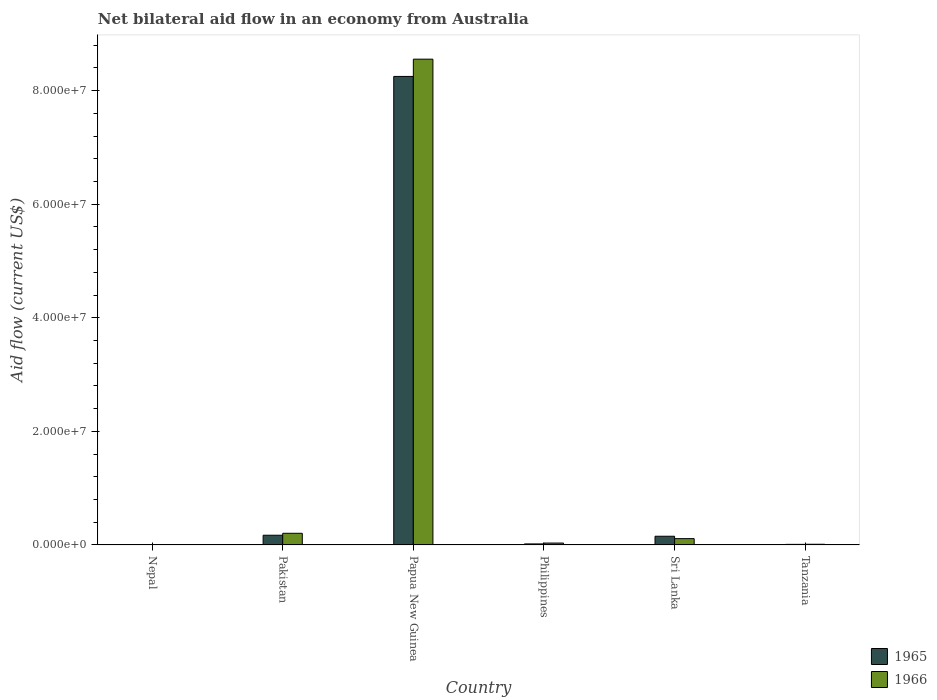How many different coloured bars are there?
Your answer should be very brief. 2. How many groups of bars are there?
Give a very brief answer. 6. Are the number of bars on each tick of the X-axis equal?
Your answer should be very brief. Yes. What is the label of the 3rd group of bars from the left?
Give a very brief answer. Papua New Guinea. What is the net bilateral aid flow in 1966 in Papua New Guinea?
Give a very brief answer. 8.56e+07. Across all countries, what is the maximum net bilateral aid flow in 1965?
Offer a very short reply. 8.25e+07. In which country was the net bilateral aid flow in 1965 maximum?
Provide a short and direct response. Papua New Guinea. In which country was the net bilateral aid flow in 1965 minimum?
Your answer should be compact. Nepal. What is the total net bilateral aid flow in 1965 in the graph?
Provide a short and direct response. 8.61e+07. What is the difference between the net bilateral aid flow in 1966 in Nepal and that in Philippines?
Your answer should be compact. -2.70e+05. What is the difference between the net bilateral aid flow in 1966 in Papua New Guinea and the net bilateral aid flow in 1965 in Philippines?
Make the answer very short. 8.54e+07. What is the average net bilateral aid flow in 1966 per country?
Offer a terse response. 1.49e+07. What is the ratio of the net bilateral aid flow in 1966 in Philippines to that in Tanzania?
Give a very brief answer. 2.75. Is the net bilateral aid flow in 1965 in Philippines less than that in Sri Lanka?
Your answer should be very brief. Yes. What is the difference between the highest and the second highest net bilateral aid flow in 1966?
Offer a very short reply. 8.44e+07. What is the difference between the highest and the lowest net bilateral aid flow in 1966?
Provide a short and direct response. 8.55e+07. What does the 2nd bar from the left in Papua New Guinea represents?
Your response must be concise. 1966. What does the 2nd bar from the right in Papua New Guinea represents?
Give a very brief answer. 1965. How many bars are there?
Your answer should be compact. 12. Are the values on the major ticks of Y-axis written in scientific E-notation?
Offer a terse response. Yes. What is the title of the graph?
Make the answer very short. Net bilateral aid flow in an economy from Australia. What is the Aid flow (current US$) in 1965 in Nepal?
Ensure brevity in your answer.  5.00e+04. What is the Aid flow (current US$) in 1965 in Pakistan?
Give a very brief answer. 1.71e+06. What is the Aid flow (current US$) of 1966 in Pakistan?
Provide a short and direct response. 2.05e+06. What is the Aid flow (current US$) in 1965 in Papua New Guinea?
Offer a very short reply. 8.25e+07. What is the Aid flow (current US$) in 1966 in Papua New Guinea?
Ensure brevity in your answer.  8.56e+07. What is the Aid flow (current US$) of 1966 in Philippines?
Ensure brevity in your answer.  3.30e+05. What is the Aid flow (current US$) in 1965 in Sri Lanka?
Offer a very short reply. 1.53e+06. What is the Aid flow (current US$) of 1966 in Sri Lanka?
Your answer should be compact. 1.11e+06. What is the Aid flow (current US$) in 1965 in Tanzania?
Your response must be concise. 1.00e+05. Across all countries, what is the maximum Aid flow (current US$) in 1965?
Ensure brevity in your answer.  8.25e+07. Across all countries, what is the maximum Aid flow (current US$) of 1966?
Provide a succinct answer. 8.56e+07. Across all countries, what is the minimum Aid flow (current US$) in 1966?
Give a very brief answer. 6.00e+04. What is the total Aid flow (current US$) of 1965 in the graph?
Your answer should be compact. 8.61e+07. What is the total Aid flow (current US$) in 1966 in the graph?
Your answer should be very brief. 8.92e+07. What is the difference between the Aid flow (current US$) of 1965 in Nepal and that in Pakistan?
Make the answer very short. -1.66e+06. What is the difference between the Aid flow (current US$) in 1966 in Nepal and that in Pakistan?
Provide a succinct answer. -1.99e+06. What is the difference between the Aid flow (current US$) of 1965 in Nepal and that in Papua New Guinea?
Keep it short and to the point. -8.25e+07. What is the difference between the Aid flow (current US$) of 1966 in Nepal and that in Papua New Guinea?
Offer a very short reply. -8.55e+07. What is the difference between the Aid flow (current US$) of 1966 in Nepal and that in Philippines?
Make the answer very short. -2.70e+05. What is the difference between the Aid flow (current US$) in 1965 in Nepal and that in Sri Lanka?
Make the answer very short. -1.48e+06. What is the difference between the Aid flow (current US$) in 1966 in Nepal and that in Sri Lanka?
Offer a terse response. -1.05e+06. What is the difference between the Aid flow (current US$) of 1965 in Nepal and that in Tanzania?
Your response must be concise. -5.00e+04. What is the difference between the Aid flow (current US$) in 1965 in Pakistan and that in Papua New Guinea?
Give a very brief answer. -8.08e+07. What is the difference between the Aid flow (current US$) of 1966 in Pakistan and that in Papua New Guinea?
Your response must be concise. -8.35e+07. What is the difference between the Aid flow (current US$) of 1965 in Pakistan and that in Philippines?
Ensure brevity in your answer.  1.53e+06. What is the difference between the Aid flow (current US$) of 1966 in Pakistan and that in Philippines?
Provide a short and direct response. 1.72e+06. What is the difference between the Aid flow (current US$) of 1966 in Pakistan and that in Sri Lanka?
Give a very brief answer. 9.40e+05. What is the difference between the Aid flow (current US$) in 1965 in Pakistan and that in Tanzania?
Provide a short and direct response. 1.61e+06. What is the difference between the Aid flow (current US$) of 1966 in Pakistan and that in Tanzania?
Provide a succinct answer. 1.93e+06. What is the difference between the Aid flow (current US$) in 1965 in Papua New Guinea and that in Philippines?
Provide a succinct answer. 8.23e+07. What is the difference between the Aid flow (current US$) of 1966 in Papua New Guinea and that in Philippines?
Your response must be concise. 8.52e+07. What is the difference between the Aid flow (current US$) of 1965 in Papua New Guinea and that in Sri Lanka?
Your answer should be very brief. 8.10e+07. What is the difference between the Aid flow (current US$) of 1966 in Papua New Guinea and that in Sri Lanka?
Provide a succinct answer. 8.44e+07. What is the difference between the Aid flow (current US$) of 1965 in Papua New Guinea and that in Tanzania?
Keep it short and to the point. 8.24e+07. What is the difference between the Aid flow (current US$) of 1966 in Papua New Guinea and that in Tanzania?
Your answer should be compact. 8.54e+07. What is the difference between the Aid flow (current US$) in 1965 in Philippines and that in Sri Lanka?
Offer a terse response. -1.35e+06. What is the difference between the Aid flow (current US$) of 1966 in Philippines and that in Sri Lanka?
Give a very brief answer. -7.80e+05. What is the difference between the Aid flow (current US$) in 1965 in Philippines and that in Tanzania?
Offer a very short reply. 8.00e+04. What is the difference between the Aid flow (current US$) in 1965 in Sri Lanka and that in Tanzania?
Provide a succinct answer. 1.43e+06. What is the difference between the Aid flow (current US$) in 1966 in Sri Lanka and that in Tanzania?
Offer a very short reply. 9.90e+05. What is the difference between the Aid flow (current US$) of 1965 in Nepal and the Aid flow (current US$) of 1966 in Pakistan?
Your answer should be compact. -2.00e+06. What is the difference between the Aid flow (current US$) in 1965 in Nepal and the Aid flow (current US$) in 1966 in Papua New Guinea?
Make the answer very short. -8.55e+07. What is the difference between the Aid flow (current US$) of 1965 in Nepal and the Aid flow (current US$) of 1966 in Philippines?
Give a very brief answer. -2.80e+05. What is the difference between the Aid flow (current US$) in 1965 in Nepal and the Aid flow (current US$) in 1966 in Sri Lanka?
Offer a very short reply. -1.06e+06. What is the difference between the Aid flow (current US$) of 1965 in Pakistan and the Aid flow (current US$) of 1966 in Papua New Guinea?
Provide a short and direct response. -8.38e+07. What is the difference between the Aid flow (current US$) in 1965 in Pakistan and the Aid flow (current US$) in 1966 in Philippines?
Your answer should be very brief. 1.38e+06. What is the difference between the Aid flow (current US$) of 1965 in Pakistan and the Aid flow (current US$) of 1966 in Tanzania?
Make the answer very short. 1.59e+06. What is the difference between the Aid flow (current US$) in 1965 in Papua New Guinea and the Aid flow (current US$) in 1966 in Philippines?
Provide a succinct answer. 8.22e+07. What is the difference between the Aid flow (current US$) in 1965 in Papua New Guinea and the Aid flow (current US$) in 1966 in Sri Lanka?
Make the answer very short. 8.14e+07. What is the difference between the Aid flow (current US$) of 1965 in Papua New Guinea and the Aid flow (current US$) of 1966 in Tanzania?
Give a very brief answer. 8.24e+07. What is the difference between the Aid flow (current US$) in 1965 in Philippines and the Aid flow (current US$) in 1966 in Sri Lanka?
Offer a terse response. -9.30e+05. What is the difference between the Aid flow (current US$) of 1965 in Philippines and the Aid flow (current US$) of 1966 in Tanzania?
Provide a short and direct response. 6.00e+04. What is the difference between the Aid flow (current US$) of 1965 in Sri Lanka and the Aid flow (current US$) of 1966 in Tanzania?
Provide a succinct answer. 1.41e+06. What is the average Aid flow (current US$) in 1965 per country?
Offer a terse response. 1.43e+07. What is the average Aid flow (current US$) in 1966 per country?
Give a very brief answer. 1.49e+07. What is the difference between the Aid flow (current US$) in 1965 and Aid flow (current US$) in 1966 in Nepal?
Provide a succinct answer. -10000. What is the difference between the Aid flow (current US$) in 1965 and Aid flow (current US$) in 1966 in Pakistan?
Provide a succinct answer. -3.40e+05. What is the difference between the Aid flow (current US$) in 1965 and Aid flow (current US$) in 1966 in Papua New Guinea?
Your answer should be very brief. -3.04e+06. What is the ratio of the Aid flow (current US$) in 1965 in Nepal to that in Pakistan?
Offer a very short reply. 0.03. What is the ratio of the Aid flow (current US$) of 1966 in Nepal to that in Pakistan?
Provide a succinct answer. 0.03. What is the ratio of the Aid flow (current US$) of 1965 in Nepal to that in Papua New Guinea?
Keep it short and to the point. 0. What is the ratio of the Aid flow (current US$) in 1966 in Nepal to that in Papua New Guinea?
Your answer should be compact. 0. What is the ratio of the Aid flow (current US$) of 1965 in Nepal to that in Philippines?
Your response must be concise. 0.28. What is the ratio of the Aid flow (current US$) of 1966 in Nepal to that in Philippines?
Provide a succinct answer. 0.18. What is the ratio of the Aid flow (current US$) in 1965 in Nepal to that in Sri Lanka?
Offer a very short reply. 0.03. What is the ratio of the Aid flow (current US$) in 1966 in Nepal to that in Sri Lanka?
Your answer should be very brief. 0.05. What is the ratio of the Aid flow (current US$) in 1965 in Nepal to that in Tanzania?
Offer a terse response. 0.5. What is the ratio of the Aid flow (current US$) of 1966 in Nepal to that in Tanzania?
Ensure brevity in your answer.  0.5. What is the ratio of the Aid flow (current US$) of 1965 in Pakistan to that in Papua New Guinea?
Offer a very short reply. 0.02. What is the ratio of the Aid flow (current US$) of 1966 in Pakistan to that in Papua New Guinea?
Make the answer very short. 0.02. What is the ratio of the Aid flow (current US$) in 1966 in Pakistan to that in Philippines?
Offer a terse response. 6.21. What is the ratio of the Aid flow (current US$) in 1965 in Pakistan to that in Sri Lanka?
Offer a very short reply. 1.12. What is the ratio of the Aid flow (current US$) of 1966 in Pakistan to that in Sri Lanka?
Provide a succinct answer. 1.85. What is the ratio of the Aid flow (current US$) of 1966 in Pakistan to that in Tanzania?
Your answer should be compact. 17.08. What is the ratio of the Aid flow (current US$) in 1965 in Papua New Guinea to that in Philippines?
Keep it short and to the point. 458.39. What is the ratio of the Aid flow (current US$) of 1966 in Papua New Guinea to that in Philippines?
Your response must be concise. 259.24. What is the ratio of the Aid flow (current US$) in 1965 in Papua New Guinea to that in Sri Lanka?
Ensure brevity in your answer.  53.93. What is the ratio of the Aid flow (current US$) of 1966 in Papua New Guinea to that in Sri Lanka?
Offer a very short reply. 77.07. What is the ratio of the Aid flow (current US$) of 1965 in Papua New Guinea to that in Tanzania?
Your answer should be compact. 825.1. What is the ratio of the Aid flow (current US$) of 1966 in Papua New Guinea to that in Tanzania?
Give a very brief answer. 712.92. What is the ratio of the Aid flow (current US$) in 1965 in Philippines to that in Sri Lanka?
Offer a very short reply. 0.12. What is the ratio of the Aid flow (current US$) in 1966 in Philippines to that in Sri Lanka?
Your answer should be very brief. 0.3. What is the ratio of the Aid flow (current US$) in 1965 in Philippines to that in Tanzania?
Your answer should be compact. 1.8. What is the ratio of the Aid flow (current US$) of 1966 in Philippines to that in Tanzania?
Offer a very short reply. 2.75. What is the ratio of the Aid flow (current US$) in 1965 in Sri Lanka to that in Tanzania?
Make the answer very short. 15.3. What is the ratio of the Aid flow (current US$) of 1966 in Sri Lanka to that in Tanzania?
Your response must be concise. 9.25. What is the difference between the highest and the second highest Aid flow (current US$) of 1965?
Offer a terse response. 8.08e+07. What is the difference between the highest and the second highest Aid flow (current US$) of 1966?
Provide a short and direct response. 8.35e+07. What is the difference between the highest and the lowest Aid flow (current US$) in 1965?
Provide a succinct answer. 8.25e+07. What is the difference between the highest and the lowest Aid flow (current US$) in 1966?
Your answer should be compact. 8.55e+07. 